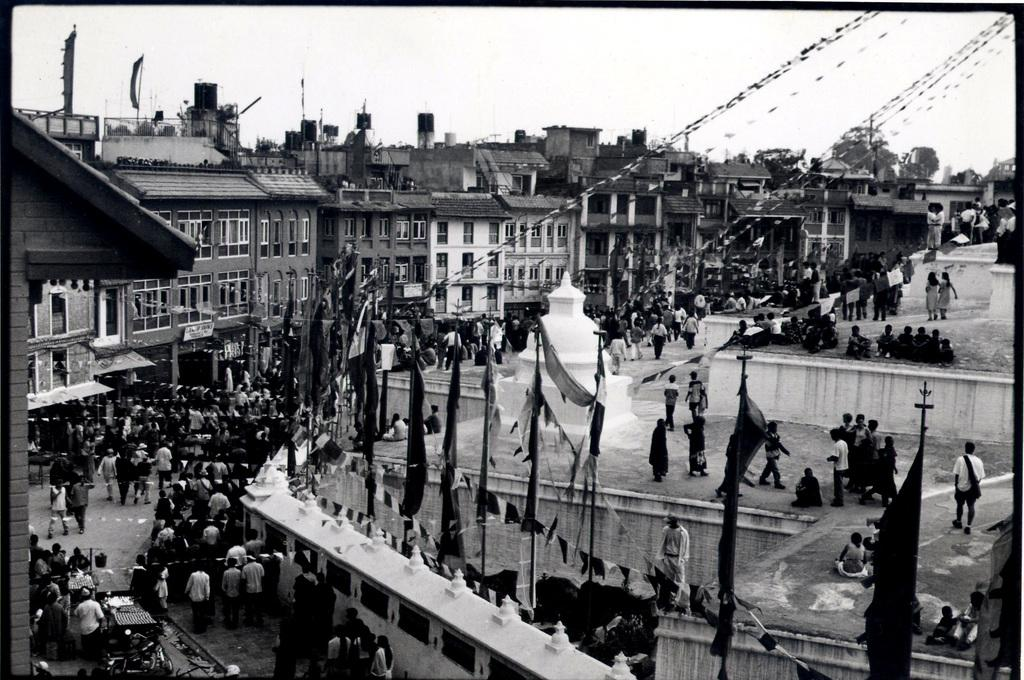What type of image is depicted in the photograph? The image contains an old photograph of a city. What can be seen within the cityscape? There are buildings visible in the photograph. What is happening in the streets of the city? There are people walking down the streets in the photograph. What decorative elements are present on the buildings? Flags are present on top of the buildings in the photograph. What type of jewel is being worn by the dolls in the image? There are no dolls or jewels present in the image; it is a photograph of a city with buildings, people, and flags. 